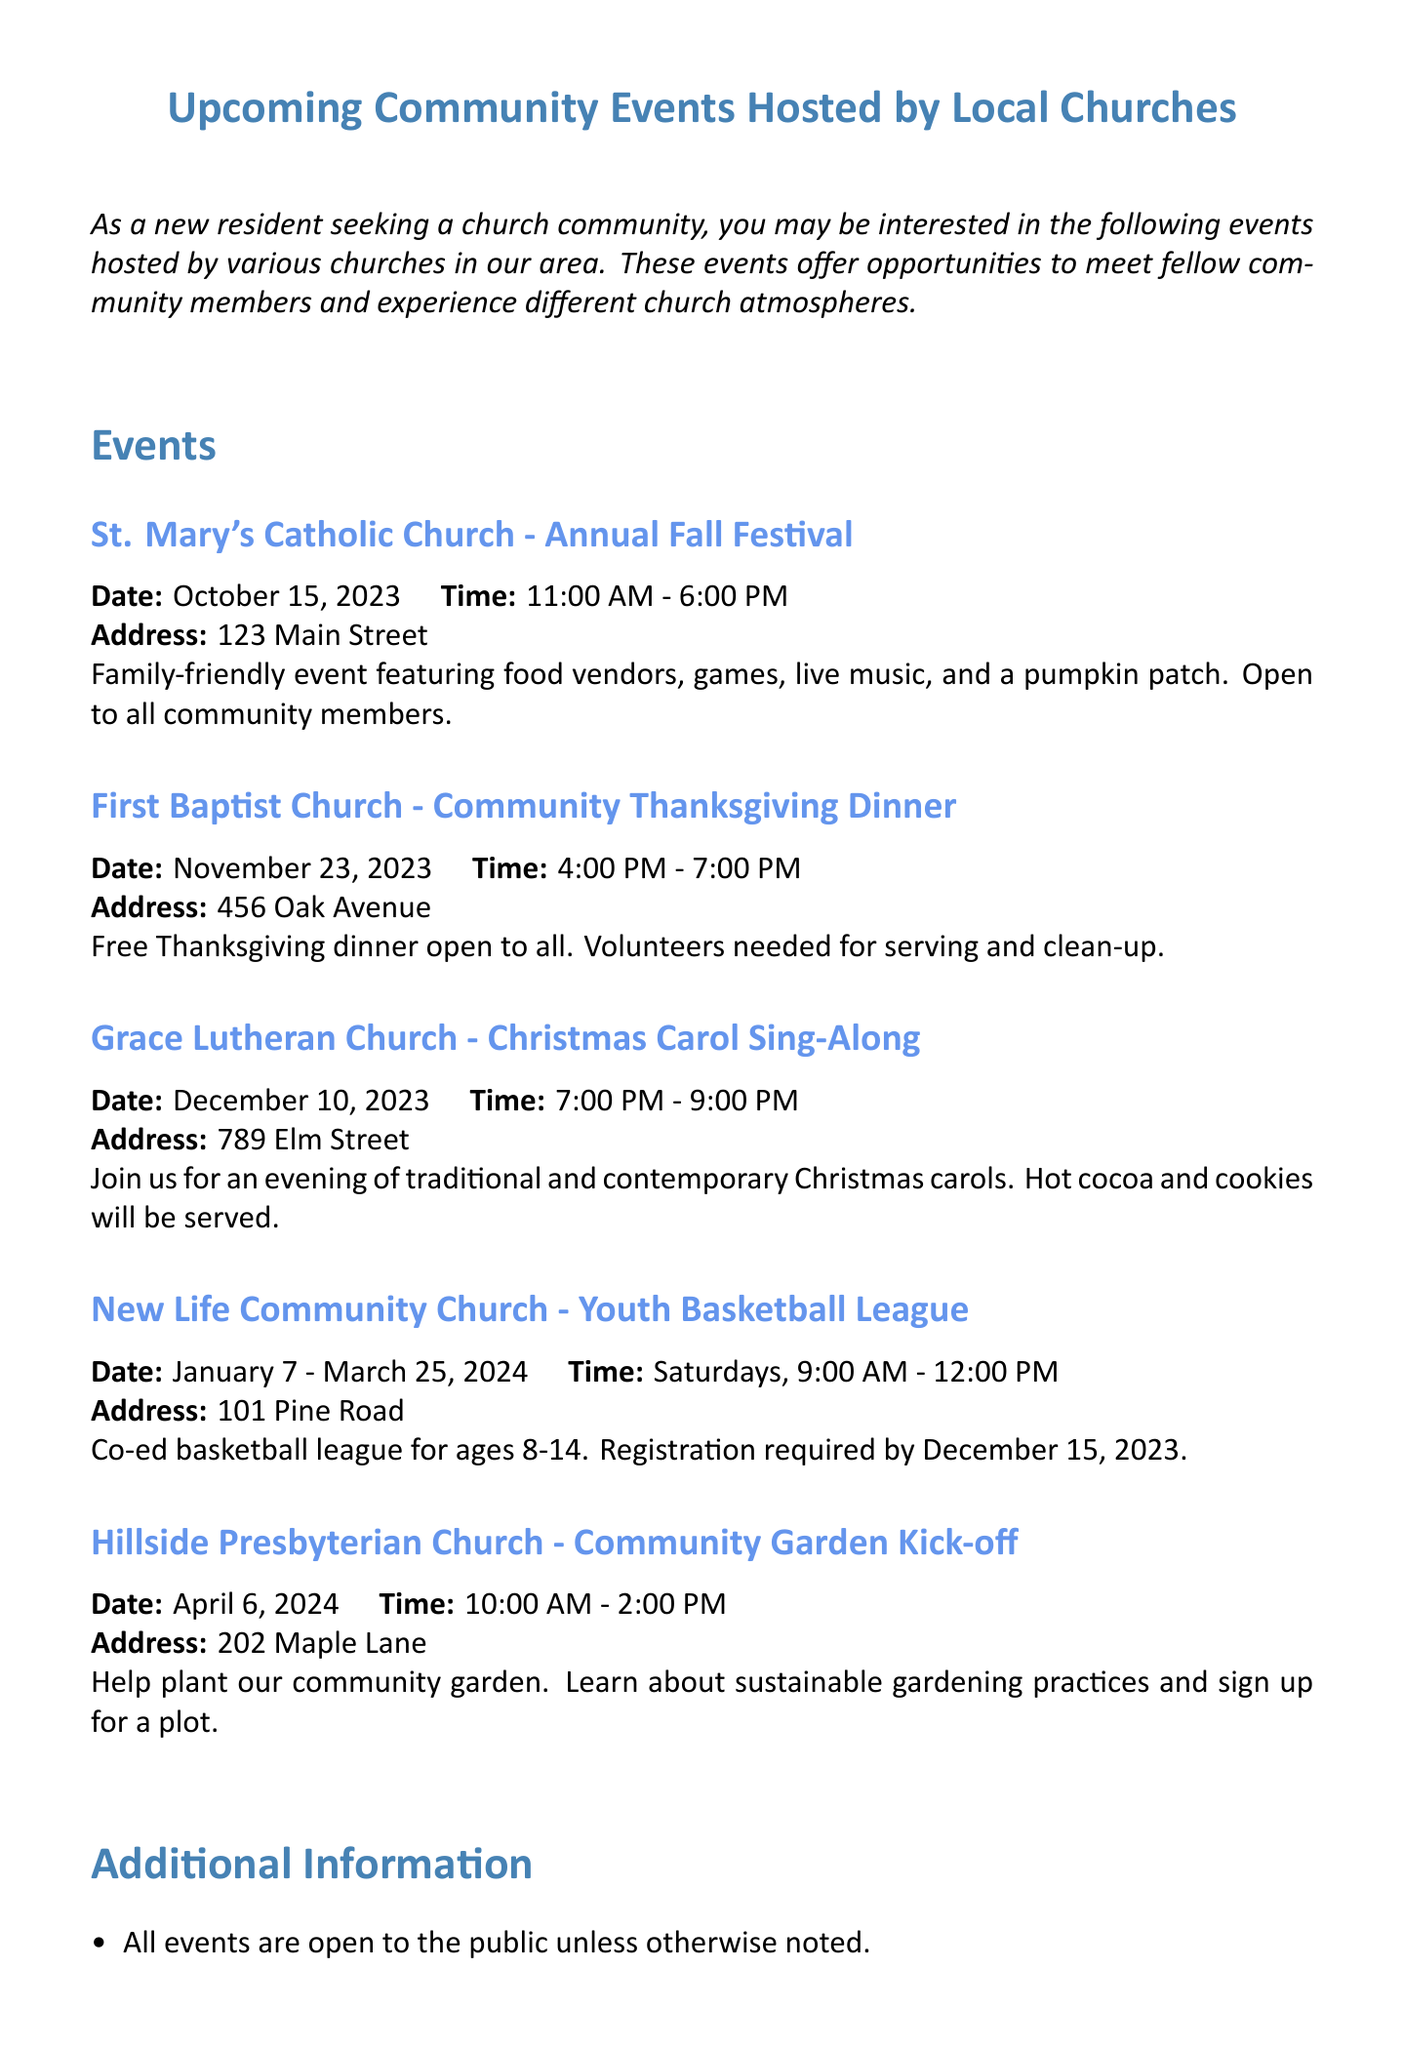What is the date of the Annual Fall Festival? The date of the Annual Fall Festival can be found in the event details for St. Mary's Catholic Church.
Answer: October 15, 2023 What time does the Community Thanksgiving Dinner start? The start time of the Community Thanksgiving Dinner is listed under the event details for First Baptist Church.
Answer: 4:00 PM Which church is hosting the Christmas Carol Sing-Along? The church that hosts the Christmas Carol Sing-Along is noted in the event description.
Answer: Grace Lutheran Church How long does the Youth Basketball League run? The duration of the Youth Basketball League is specified in the event details provided for New Life Community Church.
Answer: January 7 - March 25, 2024 What is the address of Hillside Presbyterian Church? The address for Hillside Presbyterian Church is included in the details of its community event.
Answer: 202 Maple Lane What type of event is the Community Garden Kick-off? The nature of the Community Garden Kick-off event is described in its respective section of the memo.
Answer: Help plant our community garden How many hours does the Annual Fall Festival last? The duration can be calculated from the event's start and end times.
Answer: 7 hours Who can participate in the Youth Basketball League? The participants in the Youth Basketball League are specifically mentioned in the event description.
Answer: Ages 8-14 What can attendees expect at the Christmas Carol Sing-Along? The expected offerings at the Christmas Carol Sing-Along are mentioned in the event details.
Answer: Traditional and contemporary Christmas carols 